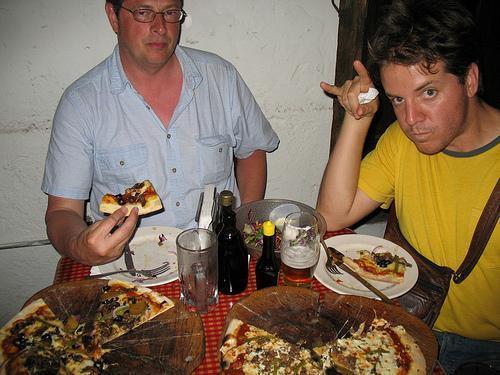How many people sleep in this image?
Give a very brief answer. 3. 